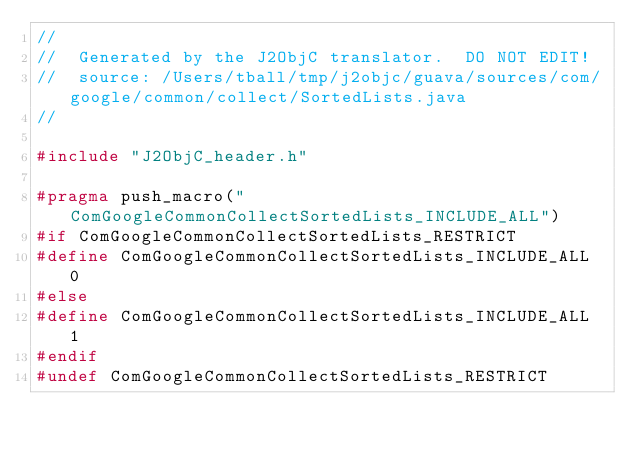<code> <loc_0><loc_0><loc_500><loc_500><_C_>//
//  Generated by the J2ObjC translator.  DO NOT EDIT!
//  source: /Users/tball/tmp/j2objc/guava/sources/com/google/common/collect/SortedLists.java
//

#include "J2ObjC_header.h"

#pragma push_macro("ComGoogleCommonCollectSortedLists_INCLUDE_ALL")
#if ComGoogleCommonCollectSortedLists_RESTRICT
#define ComGoogleCommonCollectSortedLists_INCLUDE_ALL 0
#else
#define ComGoogleCommonCollectSortedLists_INCLUDE_ALL 1
#endif
#undef ComGoogleCommonCollectSortedLists_RESTRICT
</code> 